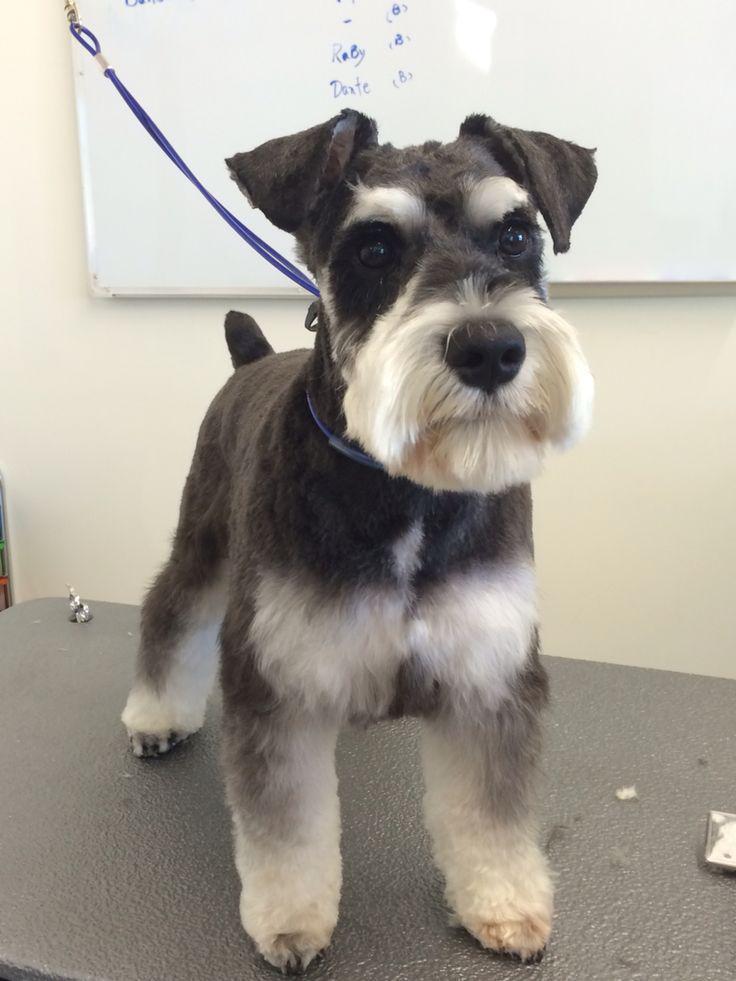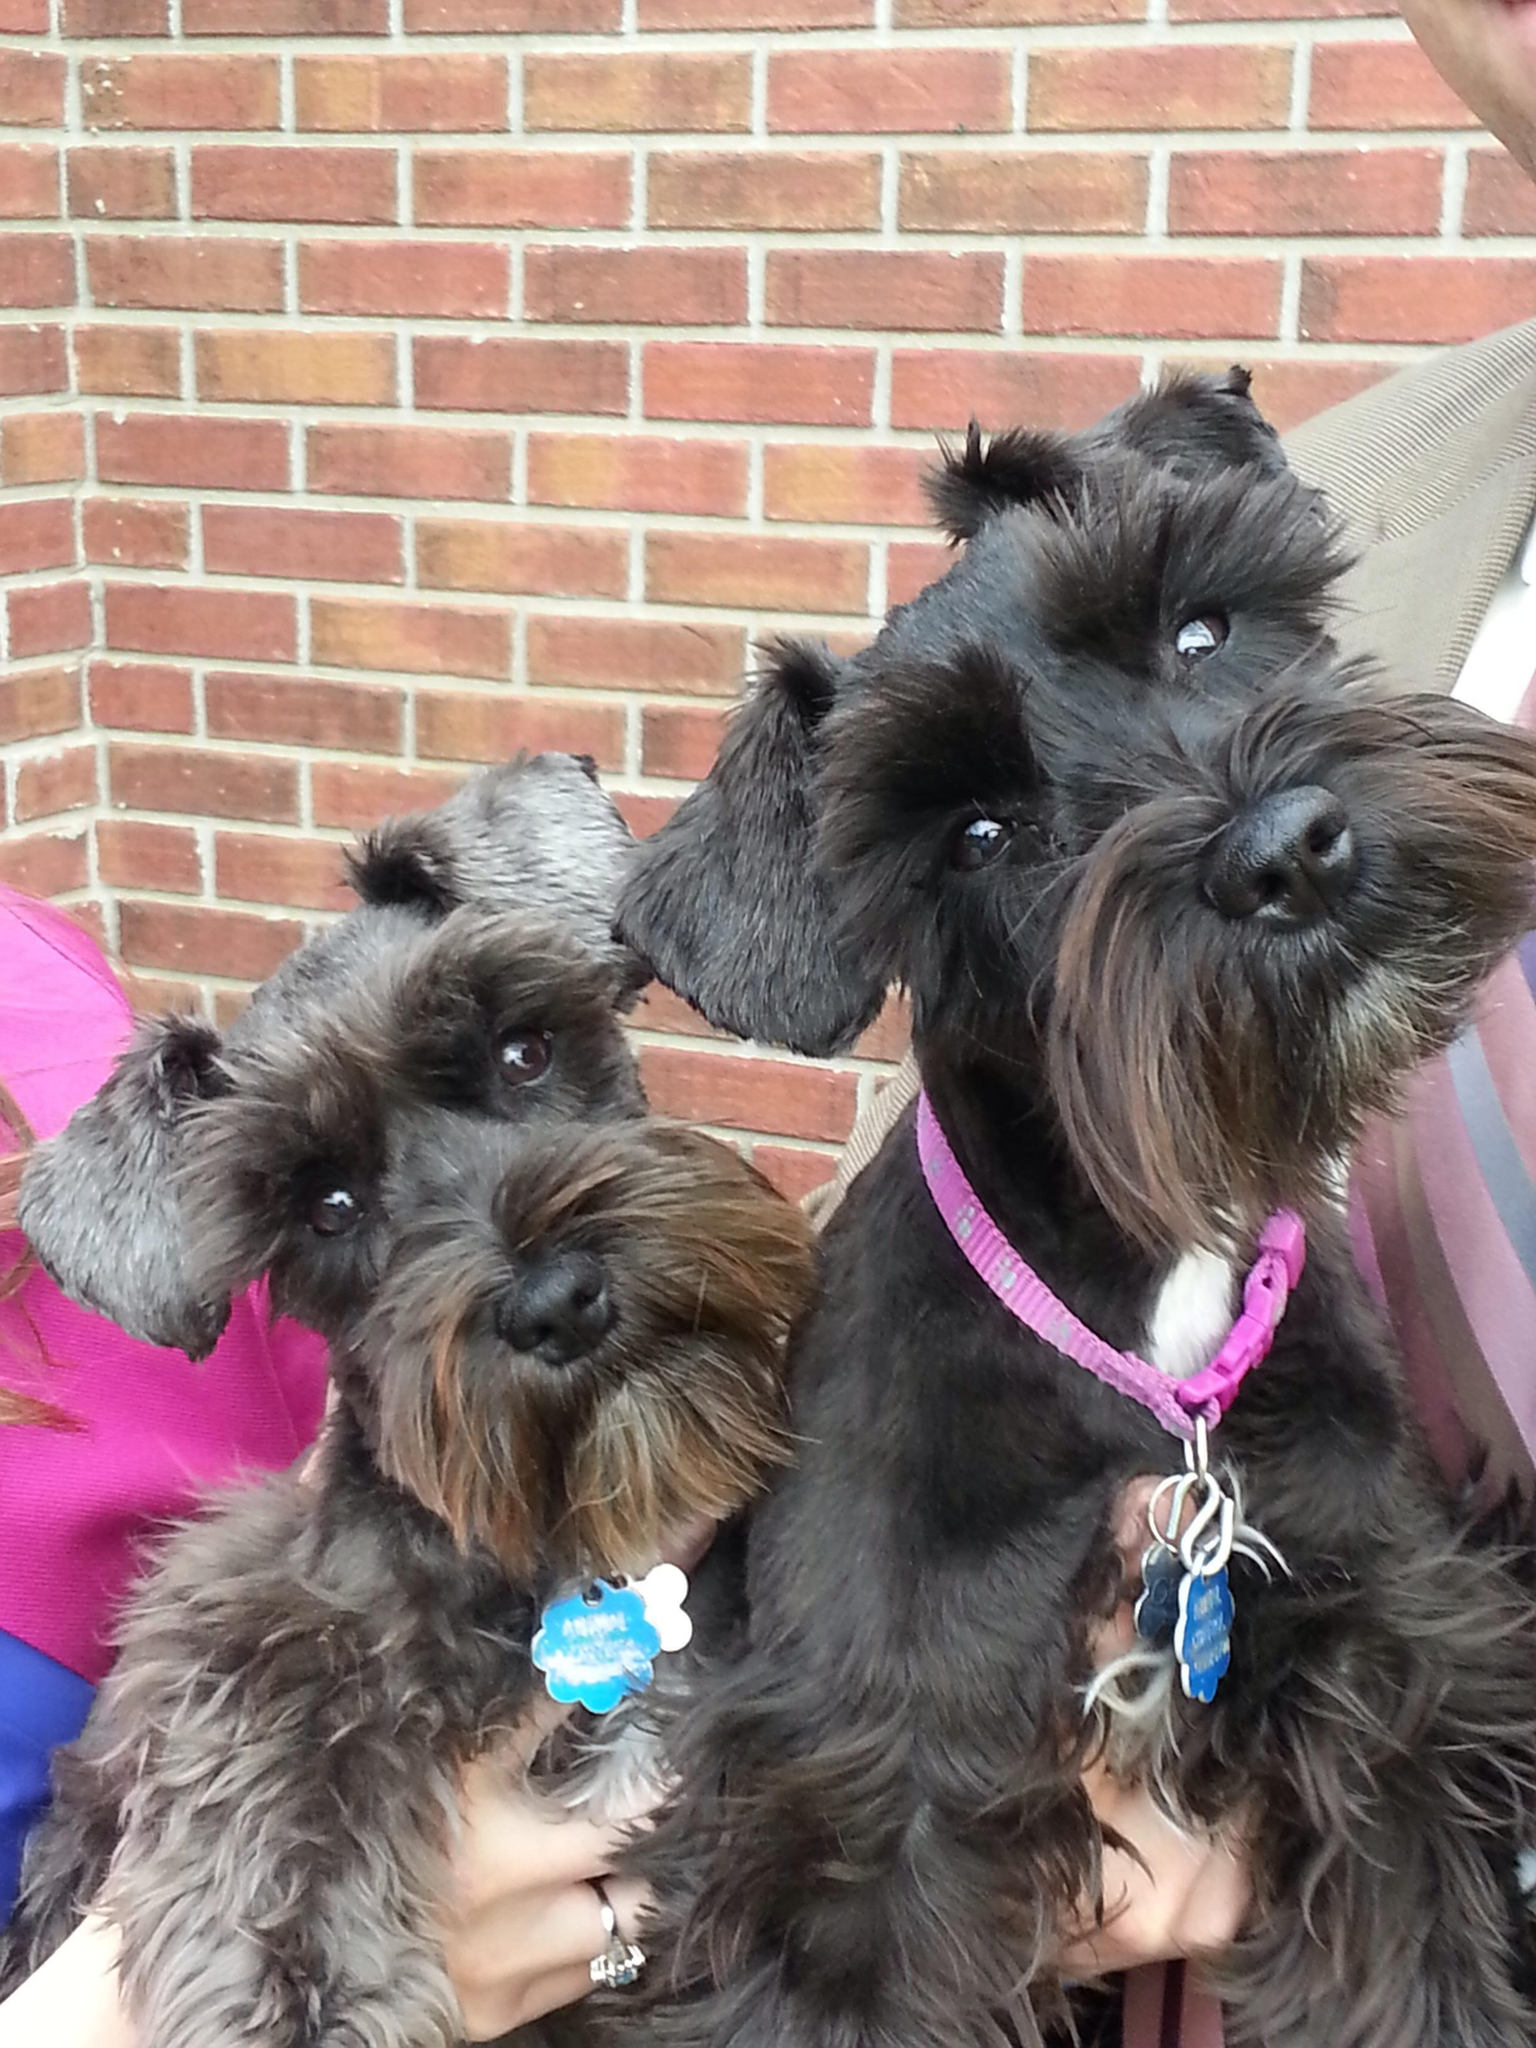The first image is the image on the left, the second image is the image on the right. For the images displayed, is the sentence "There are exactly two dogs." factually correct? Answer yes or no. No. The first image is the image on the left, the second image is the image on the right. Assess this claim about the two images: "Each image shows one forward-facing, non-standing schnauzer with a grayish coat and lighter hair on its muzzle.". Correct or not? Answer yes or no. No. 